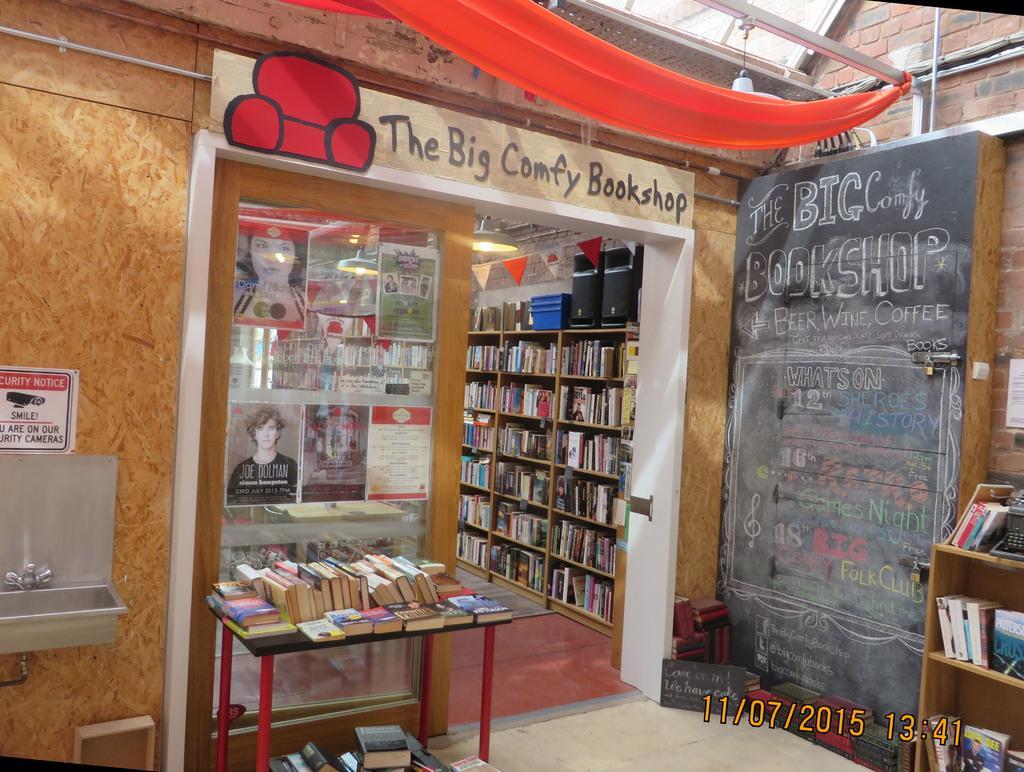Could you give a brief overview of what you see in this image? This is a picture of a bookshop, in the bookshop, we can see some shelves with books and other objects on it, there are some posters on the glass, on the wall we can see a poster and a sink, in front of the bookshop we can see a table with some books on it, there are some other books on the ground, we can see a board with text on it and also we can see some text in the shop. 